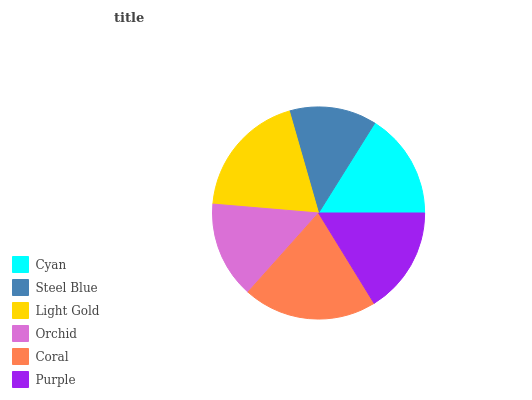Is Steel Blue the minimum?
Answer yes or no. Yes. Is Coral the maximum?
Answer yes or no. Yes. Is Light Gold the minimum?
Answer yes or no. No. Is Light Gold the maximum?
Answer yes or no. No. Is Light Gold greater than Steel Blue?
Answer yes or no. Yes. Is Steel Blue less than Light Gold?
Answer yes or no. Yes. Is Steel Blue greater than Light Gold?
Answer yes or no. No. Is Light Gold less than Steel Blue?
Answer yes or no. No. Is Purple the high median?
Answer yes or no. Yes. Is Cyan the low median?
Answer yes or no. Yes. Is Steel Blue the high median?
Answer yes or no. No. Is Coral the low median?
Answer yes or no. No. 